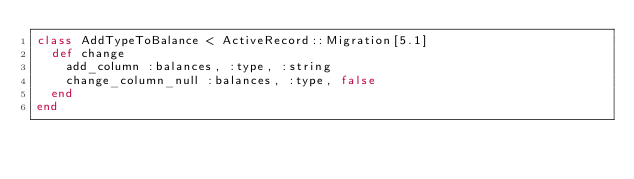<code> <loc_0><loc_0><loc_500><loc_500><_Ruby_>class AddTypeToBalance < ActiveRecord::Migration[5.1]
  def change
    add_column :balances, :type, :string
    change_column_null :balances, :type, false
  end
end
</code> 